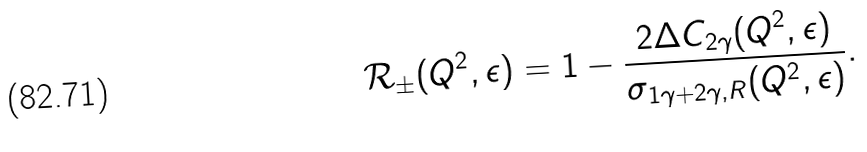<formula> <loc_0><loc_0><loc_500><loc_500>\mathcal { R } _ { \pm } ( Q ^ { 2 } , \epsilon ) = 1 - \frac { 2 \Delta C _ { 2 \gamma } ( Q ^ { 2 } , \epsilon ) } { \sigma _ { 1 \gamma + 2 \gamma , R } ( Q ^ { 2 } , \epsilon ) } .</formula> 